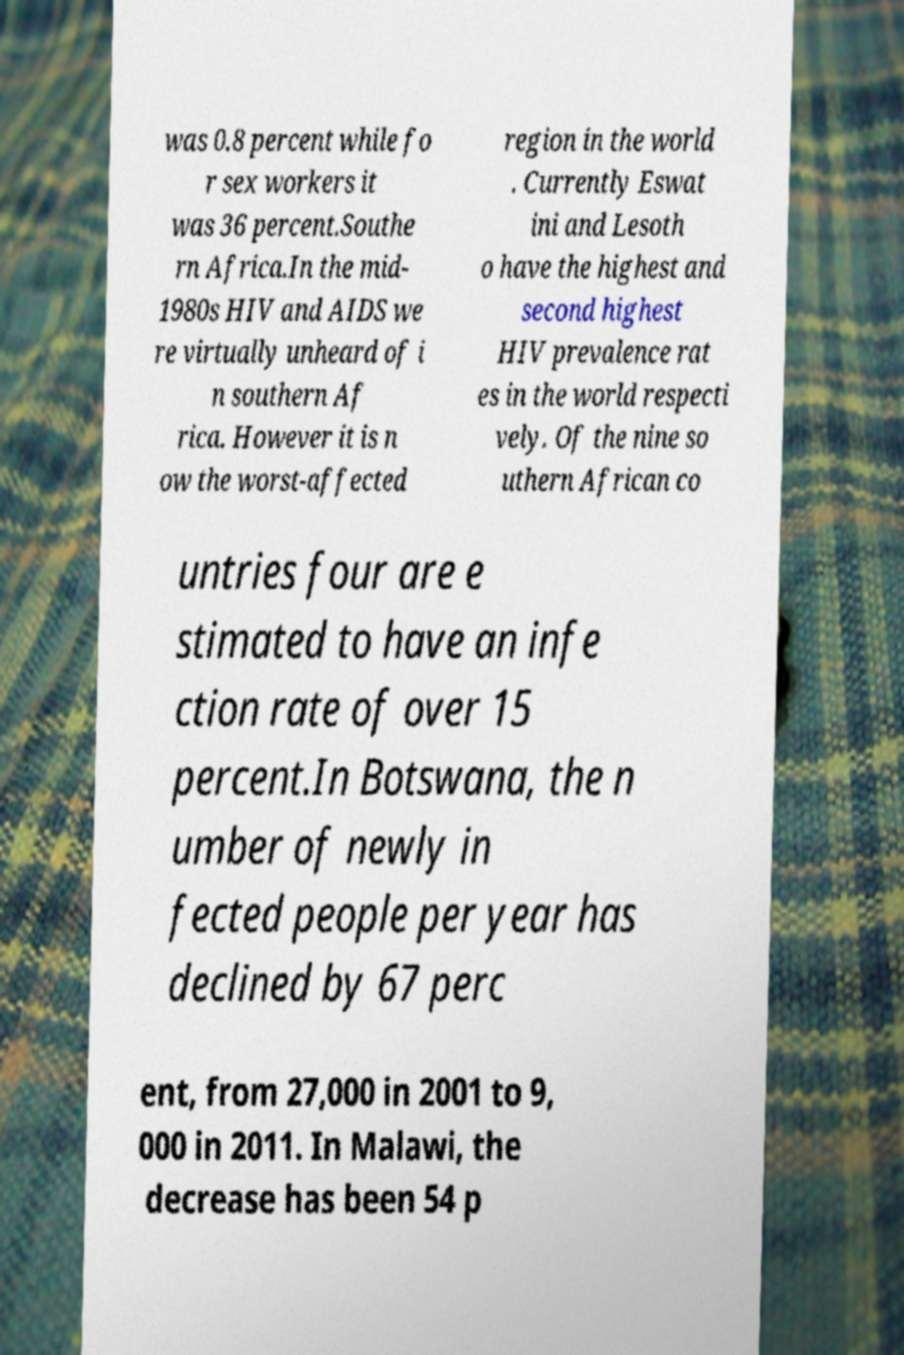There's text embedded in this image that I need extracted. Can you transcribe it verbatim? was 0.8 percent while fo r sex workers it was 36 percent.Southe rn Africa.In the mid- 1980s HIV and AIDS we re virtually unheard of i n southern Af rica. However it is n ow the worst-affected region in the world . Currently Eswat ini and Lesoth o have the highest and second highest HIV prevalence rat es in the world respecti vely. Of the nine so uthern African co untries four are e stimated to have an infe ction rate of over 15 percent.In Botswana, the n umber of newly in fected people per year has declined by 67 perc ent, from 27,000 in 2001 to 9, 000 in 2011. In Malawi, the decrease has been 54 p 